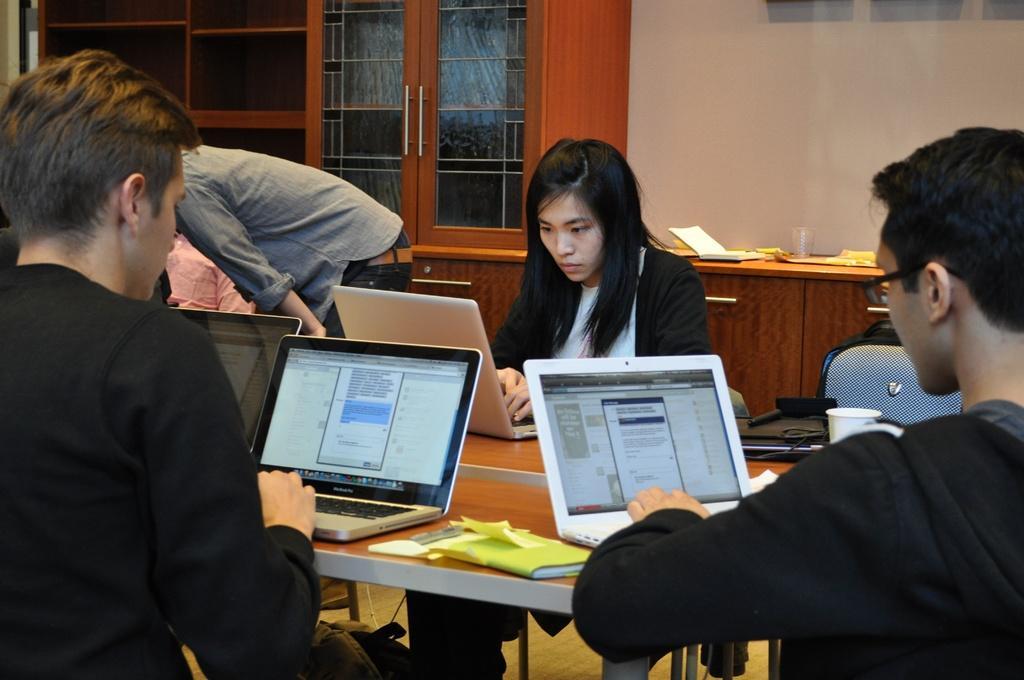Could you give a brief overview of what you see in this image? This image consists of few persons. In the front, we can see three persons sitting and using laptops. In the middle, there is a table. In the background, there are cupboards and a wall. 